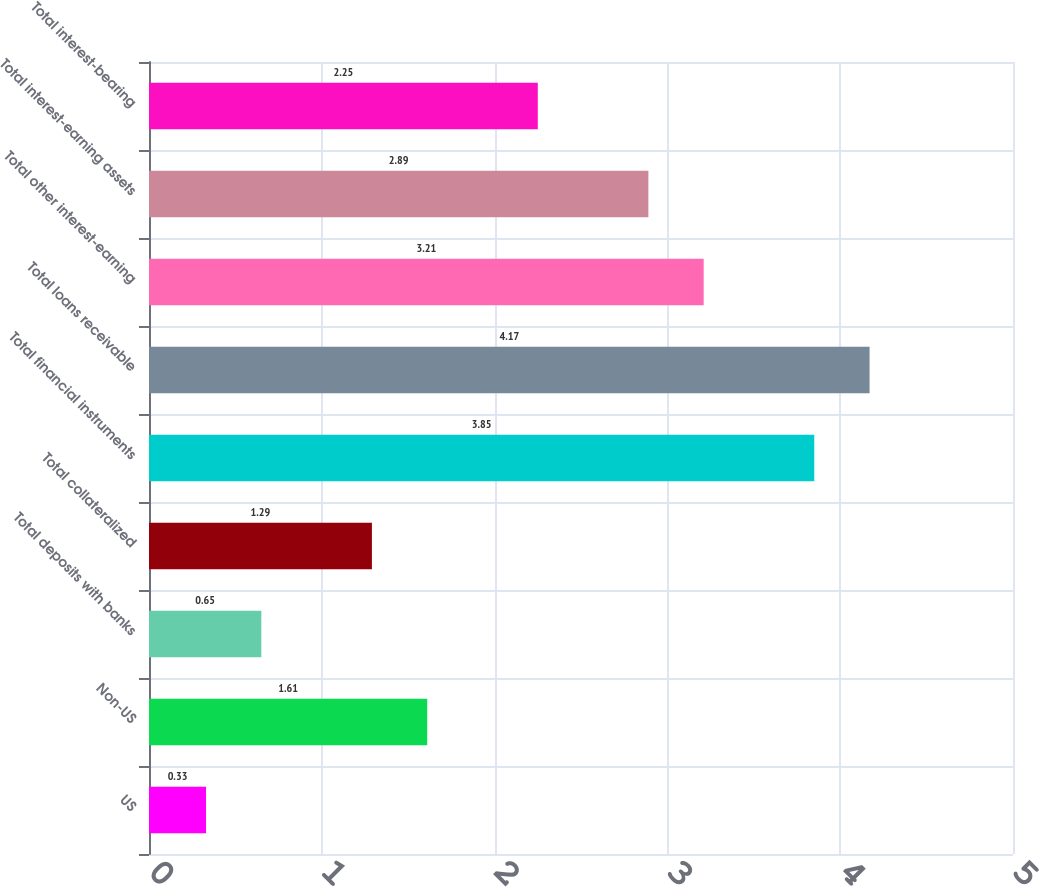<chart> <loc_0><loc_0><loc_500><loc_500><bar_chart><fcel>US<fcel>Non-US<fcel>Total deposits with banks<fcel>Total collateralized<fcel>Total financial instruments<fcel>Total loans receivable<fcel>Total other interest-earning<fcel>Total interest-earning assets<fcel>Total interest-bearing<nl><fcel>0.33<fcel>1.61<fcel>0.65<fcel>1.29<fcel>3.85<fcel>4.17<fcel>3.21<fcel>2.89<fcel>2.25<nl></chart> 